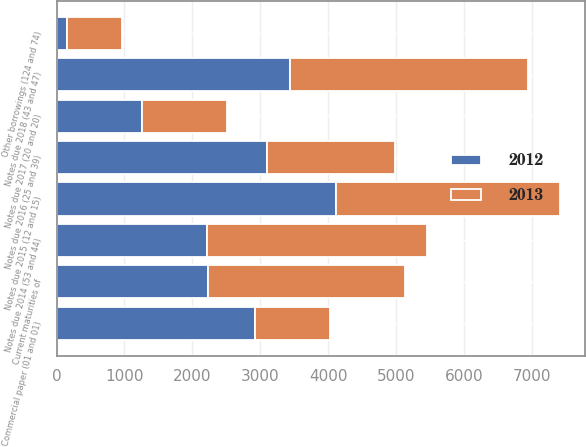Convert chart. <chart><loc_0><loc_0><loc_500><loc_500><stacked_bar_chart><ecel><fcel>Current maturities of<fcel>Commercial paper (01 and 01)<fcel>Other borrowings (124 and 74)<fcel>Notes due 2014 (53 and 44)<fcel>Notes due 2015 (12 and 15)<fcel>Notes due 2016 (25 and 39)<fcel>Notes due 2017 (20 and 20)<fcel>Notes due 2018 (43 and 47)<nl><fcel>2012<fcel>2224<fcel>2924<fcel>158<fcel>2219<fcel>4116<fcel>3106<fcel>1258<fcel>3439<nl><fcel>2013<fcel>2901<fcel>1101<fcel>813<fcel>3237<fcel>3300<fcel>1878<fcel>1250<fcel>3511<nl></chart> 